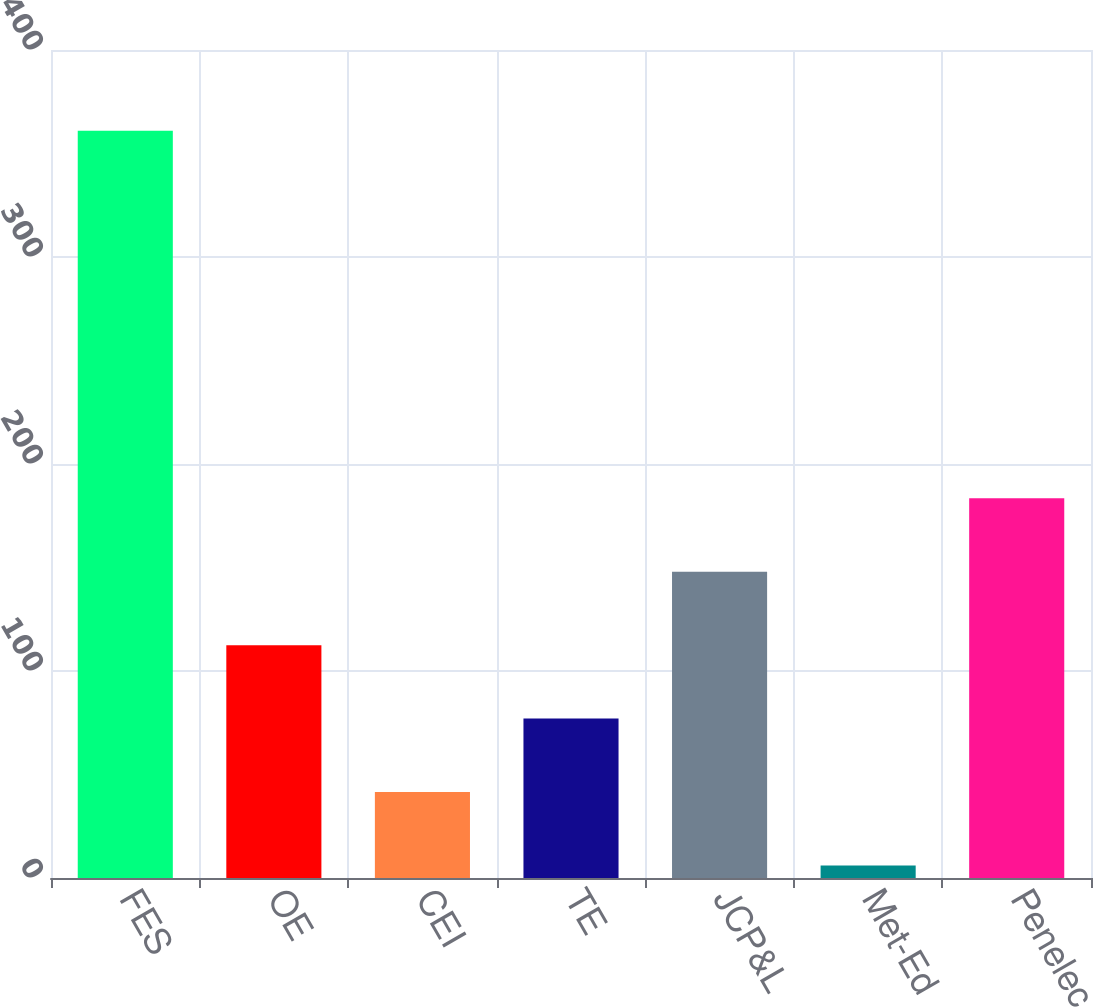Convert chart to OTSL. <chart><loc_0><loc_0><loc_500><loc_500><bar_chart><fcel>FES<fcel>OE<fcel>CEI<fcel>TE<fcel>JCP&L<fcel>Met-Ed<fcel>Penelec<nl><fcel>361<fcel>112.5<fcel>41.5<fcel>77<fcel>148<fcel>6<fcel>183.5<nl></chart> 